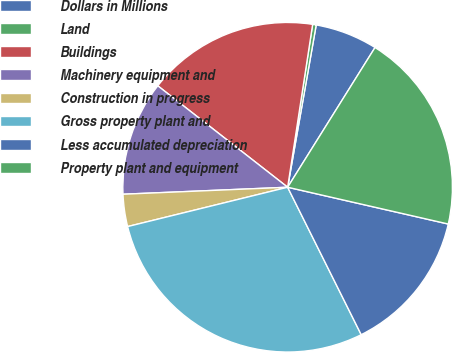Convert chart to OTSL. <chart><loc_0><loc_0><loc_500><loc_500><pie_chart><fcel>Dollars in Millions<fcel>Land<fcel>Buildings<fcel>Machinery equipment and<fcel>Construction in progress<fcel>Gross property plant and<fcel>Less accumulated depreciation<fcel>Property plant and equipment<nl><fcel>6.12%<fcel>0.35%<fcel>16.87%<fcel>11.23%<fcel>3.16%<fcel>28.53%<fcel>14.05%<fcel>19.69%<nl></chart> 